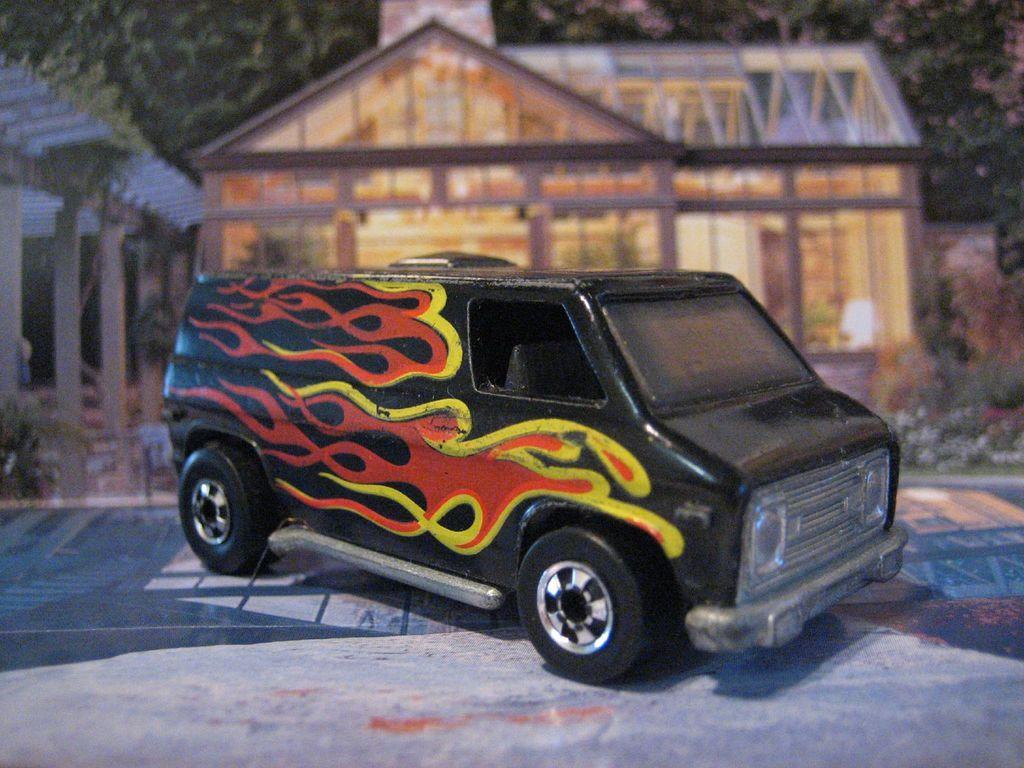In one or two sentences, can you explain what this image depicts? In this image I can see there is a toy vehicle in black color, behind this there is a wooden house with lights. On the left side there is the shed, at the top there are trees. 